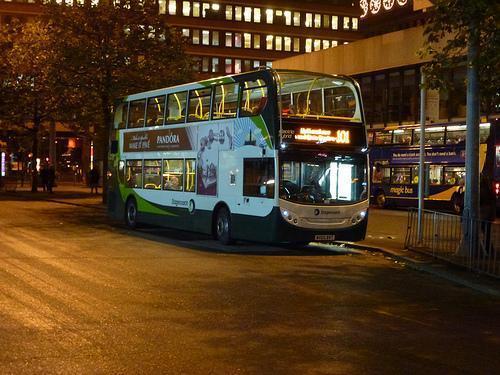How many levels do the buses have?
Give a very brief answer. 2. 